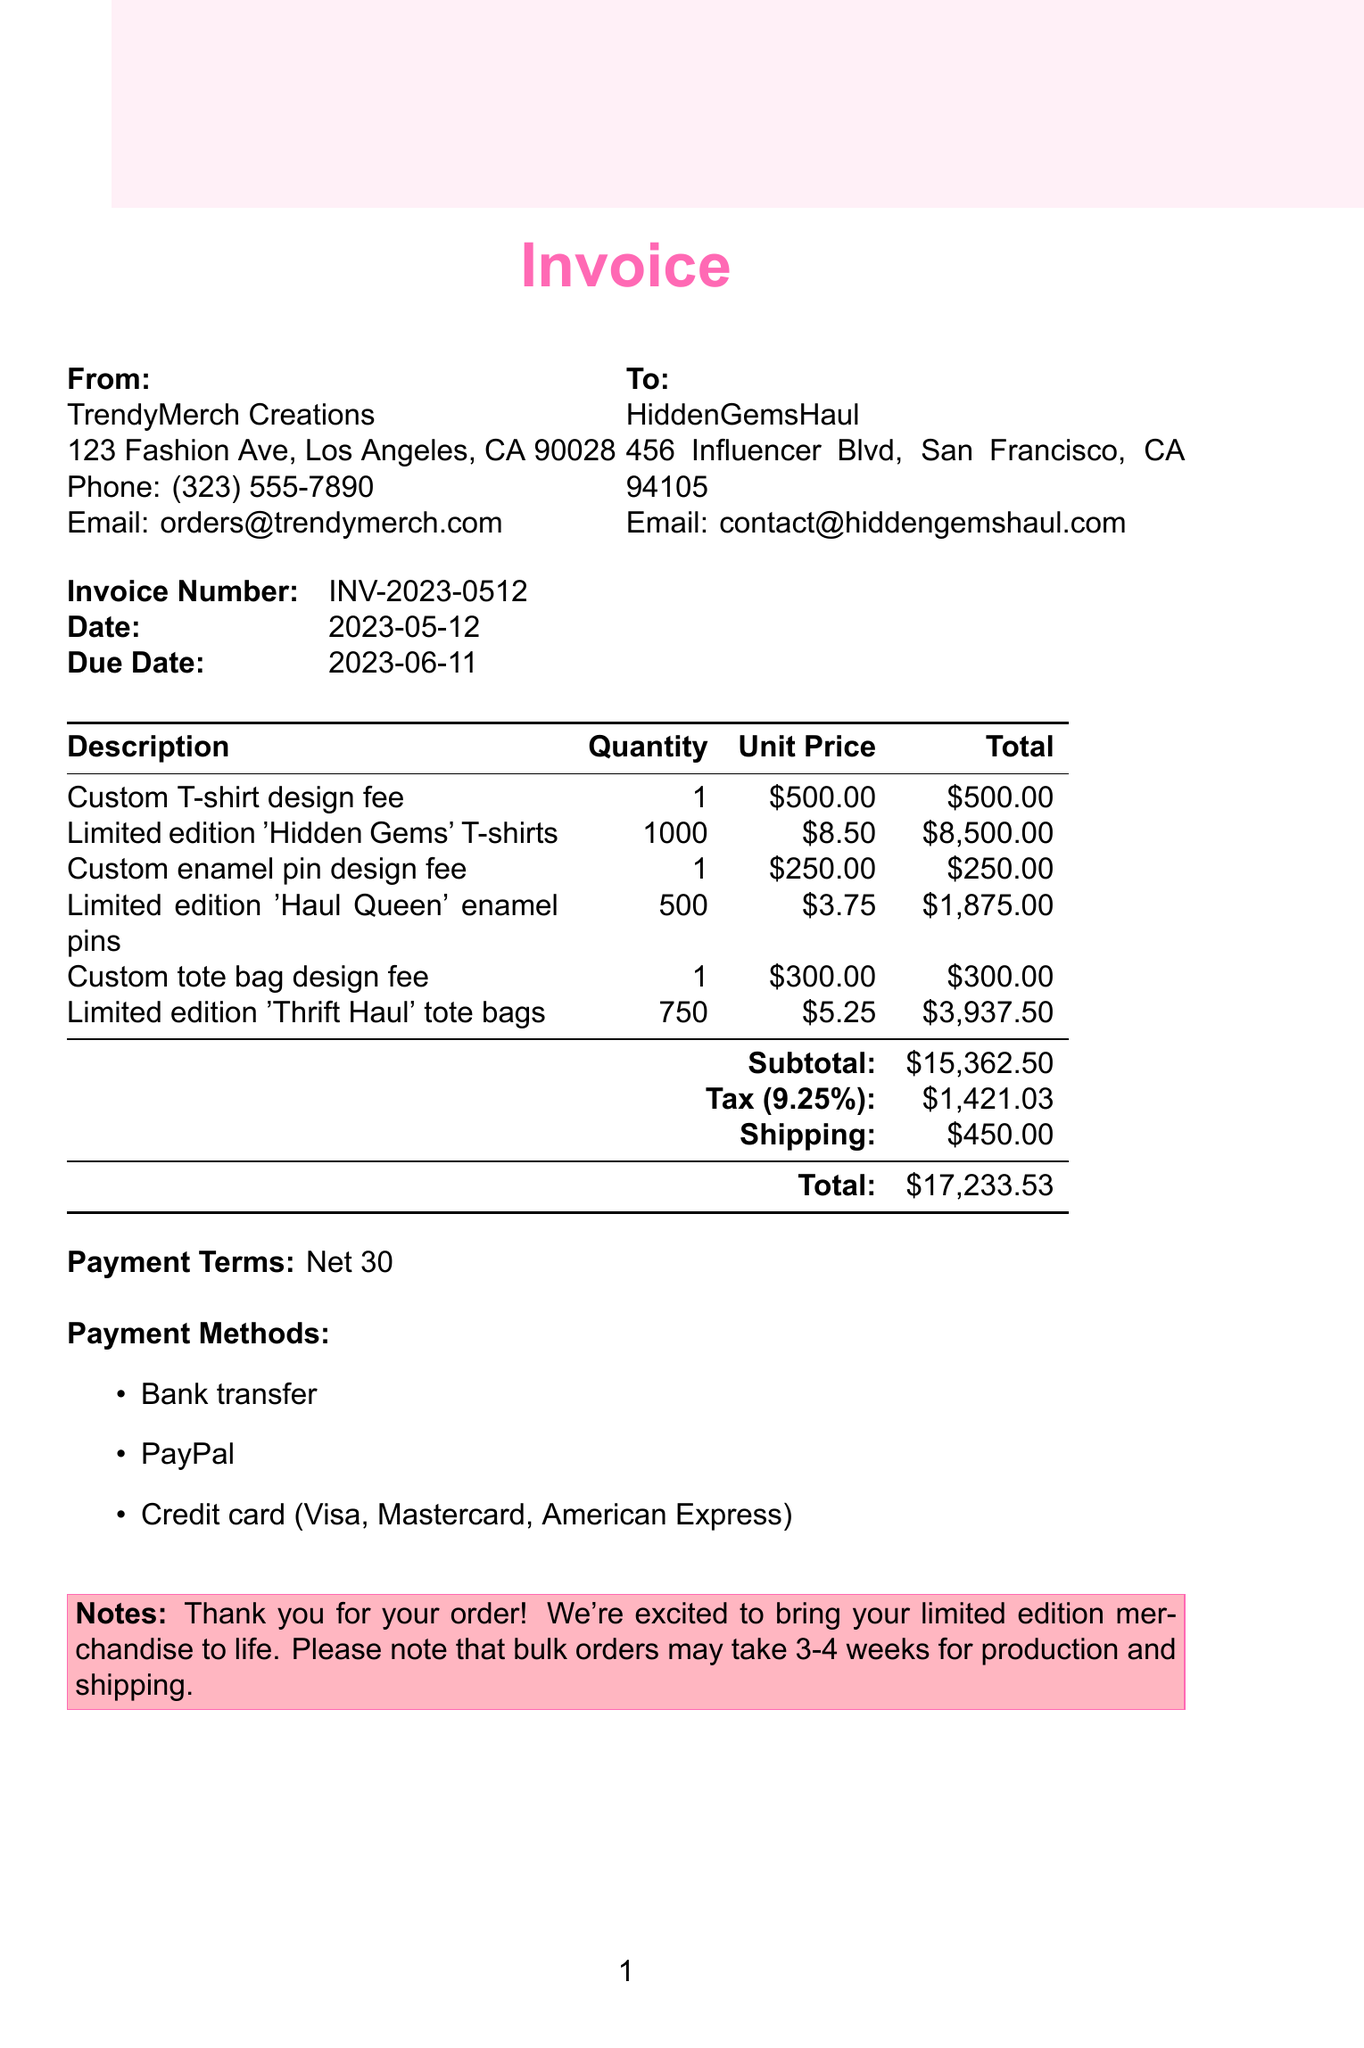What is the invoice number? The invoice number is specified in the document, which is a unique identifier for this transaction.
Answer: INV-2023-0512 What is the date of the invoice? The date of the invoice is the day it was issued, mentioned clearly in the document.
Answer: 2023-05-12 Who is the billing company? The company that issued the invoice is mentioned prominently in the document.
Answer: TrendyMerch Creations What is the total amount due? The total amount due at the end of the invoice summarizes all charges including items, tax, and shipping.
Answer: 17233.53 How many limited edition 'Haul Queen' enamel pins are being ordered? The quantity of 'Haul Queen' enamel pins is detailed under the item description.
Answer: 500 What is the subtotal before tax and shipping? The subtotal is listed as the sum of all items before additional costs, such as tax and shipping.
Answer: 15362.50 What is the due date for this invoice? The due date indicates when the payment must be completed as specified in the document.
Answer: 2023-06-11 What payment methods are accepted? Payment methods are listed to inform the client how they can pay for the invoice.
Answer: Bank transfer, PayPal, Credit card (Visa, Mastercard, American Express) What is the tax rate applied to this invoice? The tax rate is provided to show the percentage of tax that is added to the subtotal.
Answer: 9.25% What notes are included on the invoice? The notes provide additional context or appreciation related to the order and its processing timeline.
Answer: Thank you for your order! We're excited to bring your limited edition merchandise to life. Please note that bulk orders may take 3-4 weeks for production and shipping 